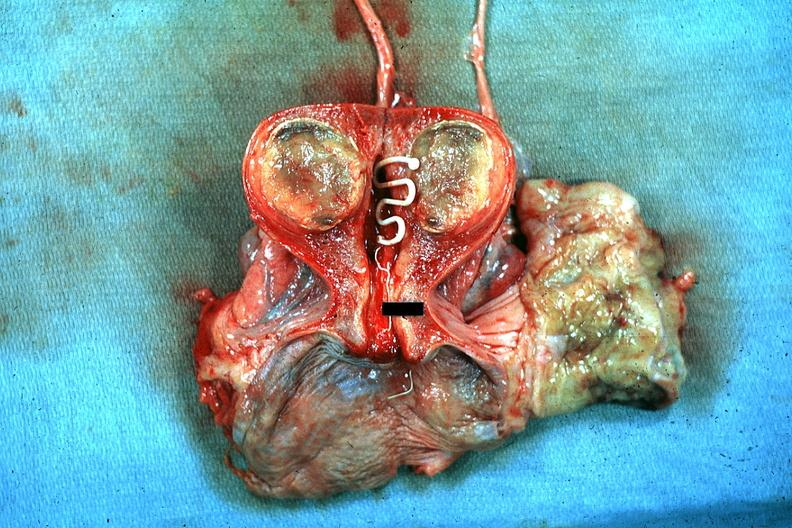s intrauterine contraceptive device present?
Answer the question using a single word or phrase. Yes 